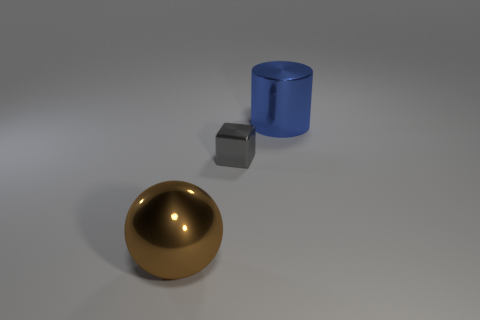Is there any indication of movement or is the scene static? The scene appears static; there are no dynamic elements such as motion blur that would suggest movement. The objects are resting on the ground, implying a stable environment without action. 